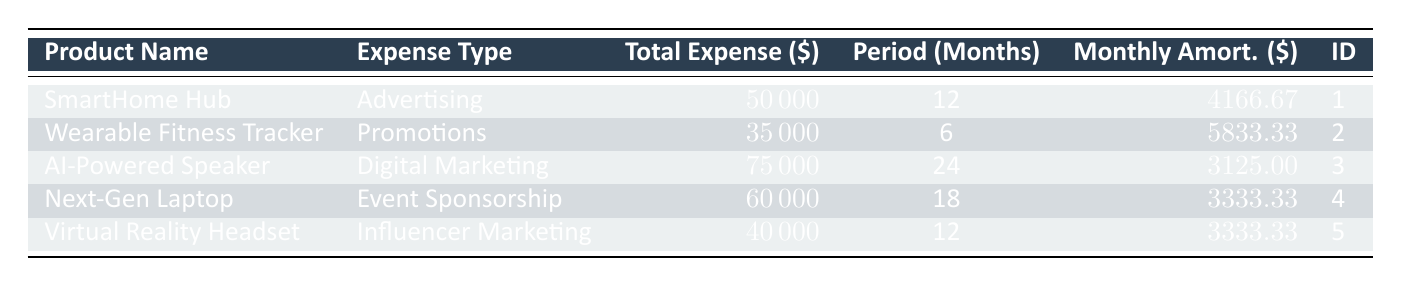What is the total expense for the "AI-Powered Speaker"? The table shows the total expenses for each product. For "AI-Powered Speaker", the total expense is listed as 75000.
Answer: 75000 Which marketing expense has the longest amortization period? The amortization periods are listed next to each product. The "AI-Powered Speaker" has a period of 24 months, which is the longest among the listed products.
Answer: AI-Powered Speaker What is the monthly amortization for the "Wearable Fitness Tracker"? The monthly amortization is provided in the table for each product. For "Wearable Fitness Tracker", it is stated as 5833.33.
Answer: 5833.33 Is the total expense for "Next-Gen Laptop" greater than the total expense for "Virtual Reality Headset"? The total expenses are compared: "Next-Gen Laptop" has a total expense of 60000 and "Virtual Reality Headset" has 40000. Since 60000 is greater than 40000, the statement is true.
Answer: Yes What is the average monthly amortization for all listed products? To find the average monthly amortization, sum the monthly amortization values (4166.67 + 5833.33 + 3125.00 + 3333.33 + 3333.33 = 18791.67) and divide by the number of products (5). The average is 18791.67 / 5 = 3758.33.
Answer: 3758.33 Which product has the highest monthly amortization, and what is its value? By comparing the monthly amortization across all products, "Wearable Fitness Tracker" has the highest at 5833.33.
Answer: Wearable Fitness Tracker, 5833.33 Is there any product type associated with "Digital Marketing"? By examining the expense type for each product, "AI-Powered Speaker" is the only product listed with "Digital Marketing" as its expense type.
Answer: Yes If we combine the total expenses of "SmartHome Hub" and "Next-Gen Laptop", what will be the total? The total expenses for "SmartHome Hub" is 50000 and for "Next-Gen Laptop" is 60000. Adding them gives 50000 + 60000 = 110000.
Answer: 110000 What is the marketing expense ID for the "Virtual Reality Headset"? The ID for "Virtual Reality Headset" is listed as 5 in the table under the ID column.
Answer: 5 